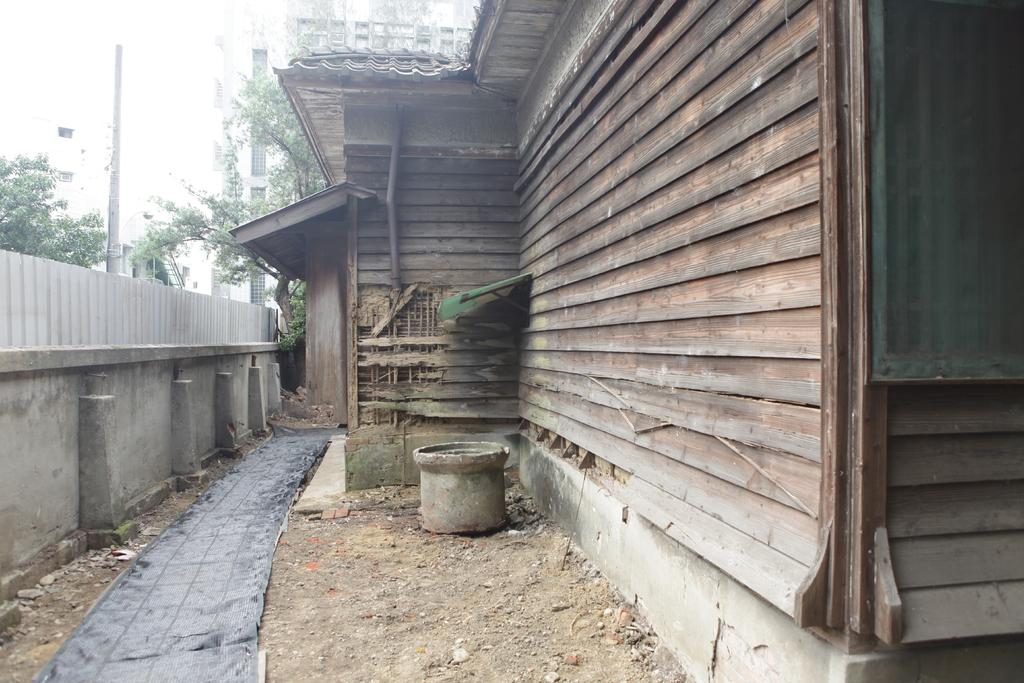What type of structures can be seen in the image? There are buildings, towers, and a wall in the image. What natural elements are present in the image? There are trees in the image. What type of material is visible in the image? There are stones in the image. What object can be found on the ground in the image? There is an object on the ground in the image. What is the opinion of the trees in the image? Trees do not have opinions, as they are inanimate objects. What is the chance of finding a shop in the image? There is no mention of a shop in the provided facts, so it cannot be determined from the image. 